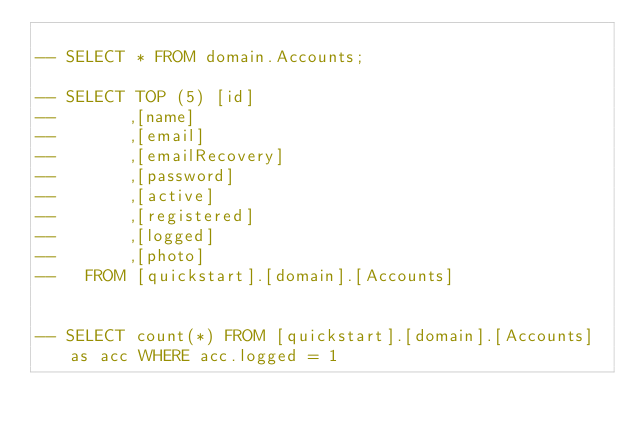Convert code to text. <code><loc_0><loc_0><loc_500><loc_500><_SQL_>
-- SELECT * FROM domain.Accounts;

-- SELECT TOP (5) [id]
--       ,[name]
--       ,[email]
--       ,[emailRecovery]
--       ,[password]
--       ,[active]
--       ,[registered]
--       ,[logged]
--       ,[photo]
--   FROM [quickstart].[domain].[Accounts]


-- SELECT count(*) FROM [quickstart].[domain].[Accounts] as acc WHERE acc.logged = 1 
</code> 